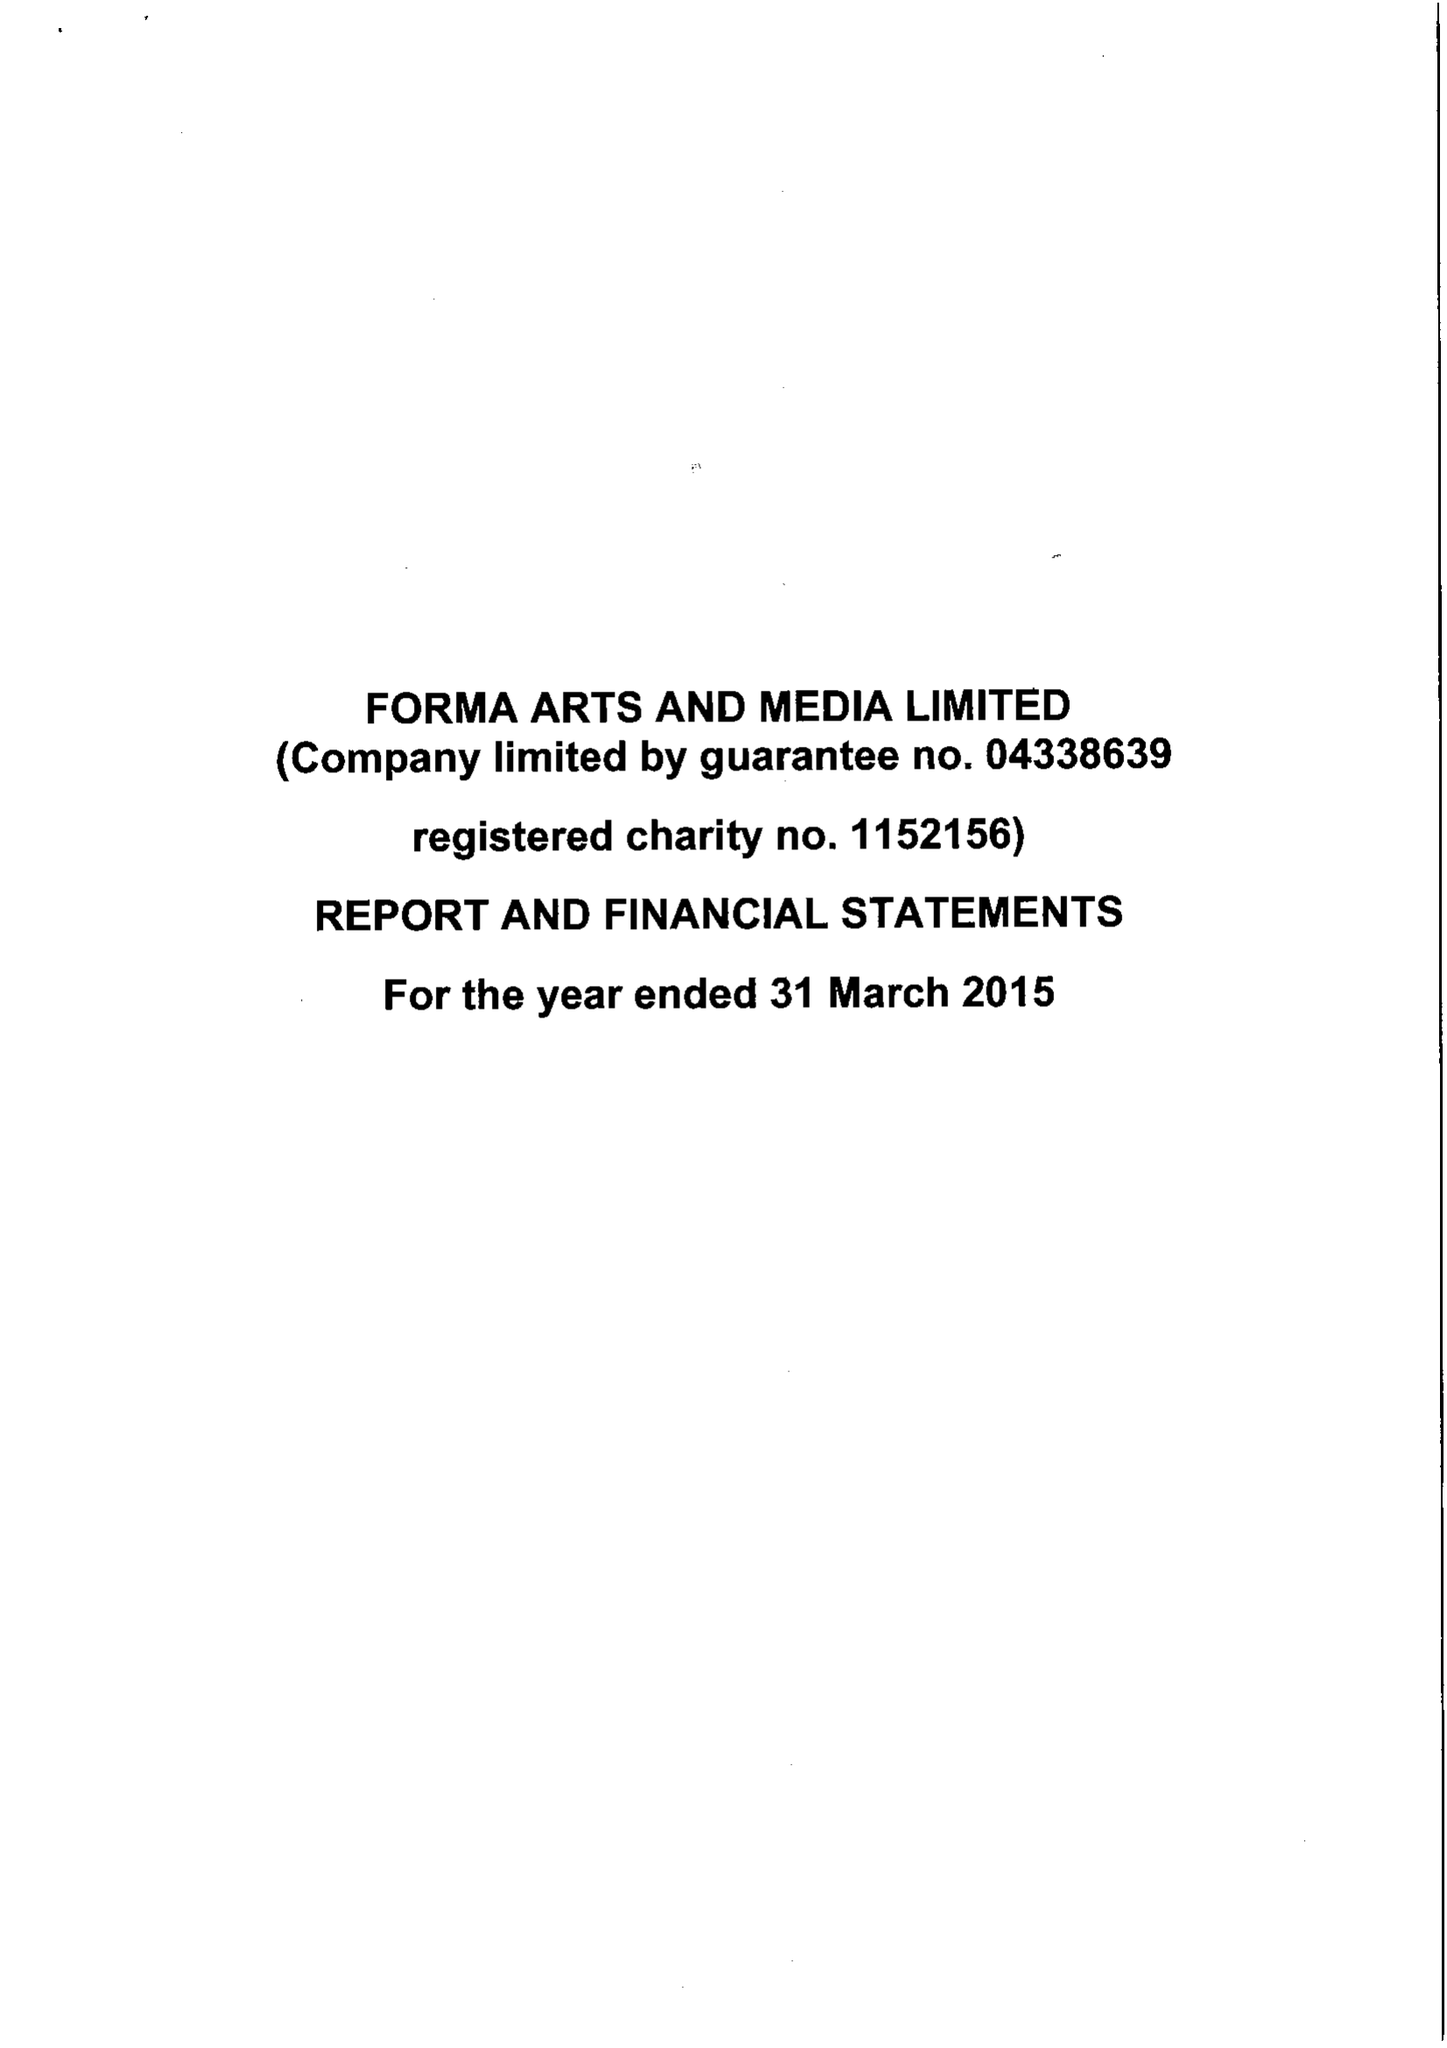What is the value for the report_date?
Answer the question using a single word or phrase. 2015-03-31 